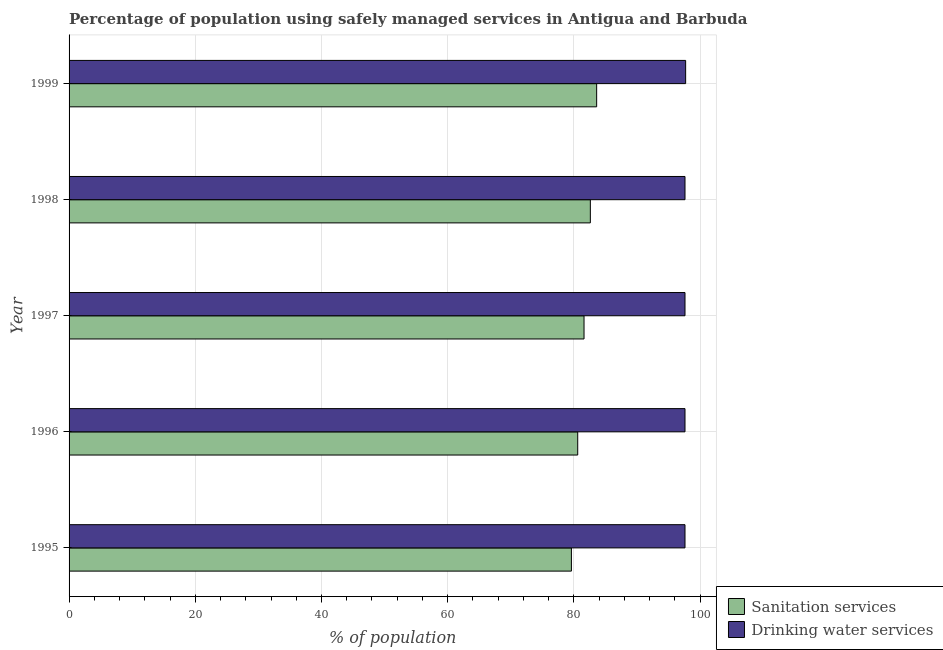In how many cases, is the number of bars for a given year not equal to the number of legend labels?
Your response must be concise. 0. What is the percentage of population who used sanitation services in 1998?
Ensure brevity in your answer.  82.6. Across all years, what is the maximum percentage of population who used drinking water services?
Ensure brevity in your answer.  97.7. Across all years, what is the minimum percentage of population who used sanitation services?
Your answer should be compact. 79.6. In which year was the percentage of population who used drinking water services minimum?
Your answer should be compact. 1995. What is the total percentage of population who used sanitation services in the graph?
Provide a succinct answer. 408. What is the difference between the percentage of population who used sanitation services in 1995 and that in 1998?
Provide a short and direct response. -3. What is the average percentage of population who used drinking water services per year?
Offer a terse response. 97.62. In the year 1995, what is the difference between the percentage of population who used sanitation services and percentage of population who used drinking water services?
Provide a succinct answer. -18. Is the percentage of population who used sanitation services in 1997 less than that in 1999?
Keep it short and to the point. Yes. Is the difference between the percentage of population who used sanitation services in 1995 and 1999 greater than the difference between the percentage of population who used drinking water services in 1995 and 1999?
Offer a very short reply. No. What is the difference between the highest and the second highest percentage of population who used drinking water services?
Keep it short and to the point. 0.1. What is the difference between the highest and the lowest percentage of population who used sanitation services?
Offer a terse response. 4. In how many years, is the percentage of population who used drinking water services greater than the average percentage of population who used drinking water services taken over all years?
Give a very brief answer. 1. What does the 2nd bar from the top in 1996 represents?
Provide a short and direct response. Sanitation services. What does the 1st bar from the bottom in 1999 represents?
Provide a short and direct response. Sanitation services. Does the graph contain any zero values?
Offer a very short reply. No. How are the legend labels stacked?
Your response must be concise. Vertical. What is the title of the graph?
Keep it short and to the point. Percentage of population using safely managed services in Antigua and Barbuda. Does "Number of arrivals" appear as one of the legend labels in the graph?
Offer a very short reply. No. What is the label or title of the X-axis?
Provide a short and direct response. % of population. What is the % of population of Sanitation services in 1995?
Your answer should be very brief. 79.6. What is the % of population of Drinking water services in 1995?
Make the answer very short. 97.6. What is the % of population of Sanitation services in 1996?
Your answer should be very brief. 80.6. What is the % of population in Drinking water services in 1996?
Give a very brief answer. 97.6. What is the % of population of Sanitation services in 1997?
Your response must be concise. 81.6. What is the % of population of Drinking water services in 1997?
Your answer should be very brief. 97.6. What is the % of population in Sanitation services in 1998?
Offer a very short reply. 82.6. What is the % of population of Drinking water services in 1998?
Offer a terse response. 97.6. What is the % of population of Sanitation services in 1999?
Provide a succinct answer. 83.6. What is the % of population in Drinking water services in 1999?
Keep it short and to the point. 97.7. Across all years, what is the maximum % of population of Sanitation services?
Ensure brevity in your answer.  83.6. Across all years, what is the maximum % of population of Drinking water services?
Keep it short and to the point. 97.7. Across all years, what is the minimum % of population in Sanitation services?
Your answer should be very brief. 79.6. Across all years, what is the minimum % of population of Drinking water services?
Provide a succinct answer. 97.6. What is the total % of population in Sanitation services in the graph?
Offer a terse response. 408. What is the total % of population in Drinking water services in the graph?
Your answer should be very brief. 488.1. What is the difference between the % of population of Sanitation services in 1995 and that in 1996?
Your answer should be compact. -1. What is the difference between the % of population in Drinking water services in 1995 and that in 1997?
Your answer should be very brief. 0. What is the difference between the % of population in Sanitation services in 1995 and that in 1998?
Offer a very short reply. -3. What is the difference between the % of population in Sanitation services in 1996 and that in 1997?
Keep it short and to the point. -1. What is the difference between the % of population of Drinking water services in 1996 and that in 1997?
Offer a terse response. 0. What is the difference between the % of population in Drinking water services in 1996 and that in 1998?
Make the answer very short. 0. What is the difference between the % of population of Sanitation services in 1996 and that in 1999?
Keep it short and to the point. -3. What is the difference between the % of population in Sanitation services in 1998 and that in 1999?
Your answer should be compact. -1. What is the difference between the % of population of Drinking water services in 1998 and that in 1999?
Keep it short and to the point. -0.1. What is the difference between the % of population of Sanitation services in 1995 and the % of population of Drinking water services in 1997?
Your answer should be compact. -18. What is the difference between the % of population of Sanitation services in 1995 and the % of population of Drinking water services in 1999?
Offer a terse response. -18.1. What is the difference between the % of population of Sanitation services in 1996 and the % of population of Drinking water services in 1997?
Provide a succinct answer. -17. What is the difference between the % of population of Sanitation services in 1996 and the % of population of Drinking water services in 1999?
Your answer should be very brief. -17.1. What is the difference between the % of population in Sanitation services in 1997 and the % of population in Drinking water services in 1998?
Your response must be concise. -16. What is the difference between the % of population of Sanitation services in 1997 and the % of population of Drinking water services in 1999?
Your response must be concise. -16.1. What is the difference between the % of population of Sanitation services in 1998 and the % of population of Drinking water services in 1999?
Ensure brevity in your answer.  -15.1. What is the average % of population in Sanitation services per year?
Your answer should be compact. 81.6. What is the average % of population in Drinking water services per year?
Give a very brief answer. 97.62. In the year 1995, what is the difference between the % of population of Sanitation services and % of population of Drinking water services?
Your response must be concise. -18. In the year 1998, what is the difference between the % of population of Sanitation services and % of population of Drinking water services?
Keep it short and to the point. -15. In the year 1999, what is the difference between the % of population of Sanitation services and % of population of Drinking water services?
Your answer should be very brief. -14.1. What is the ratio of the % of population of Sanitation services in 1995 to that in 1996?
Provide a succinct answer. 0.99. What is the ratio of the % of population in Drinking water services in 1995 to that in 1996?
Make the answer very short. 1. What is the ratio of the % of population of Sanitation services in 1995 to that in 1997?
Make the answer very short. 0.98. What is the ratio of the % of population in Sanitation services in 1995 to that in 1998?
Your response must be concise. 0.96. What is the ratio of the % of population in Drinking water services in 1995 to that in 1998?
Ensure brevity in your answer.  1. What is the ratio of the % of population in Sanitation services in 1995 to that in 1999?
Keep it short and to the point. 0.95. What is the ratio of the % of population in Drinking water services in 1995 to that in 1999?
Make the answer very short. 1. What is the ratio of the % of population of Sanitation services in 1996 to that in 1997?
Offer a terse response. 0.99. What is the ratio of the % of population of Sanitation services in 1996 to that in 1998?
Provide a succinct answer. 0.98. What is the ratio of the % of population in Drinking water services in 1996 to that in 1998?
Provide a short and direct response. 1. What is the ratio of the % of population of Sanitation services in 1996 to that in 1999?
Offer a very short reply. 0.96. What is the ratio of the % of population in Drinking water services in 1996 to that in 1999?
Your response must be concise. 1. What is the ratio of the % of population in Sanitation services in 1997 to that in 1998?
Your answer should be very brief. 0.99. What is the ratio of the % of population of Drinking water services in 1997 to that in 1998?
Give a very brief answer. 1. What is the ratio of the % of population in Sanitation services in 1997 to that in 1999?
Provide a short and direct response. 0.98. What is the difference between the highest and the second highest % of population in Sanitation services?
Your response must be concise. 1. What is the difference between the highest and the second highest % of population of Drinking water services?
Your answer should be very brief. 0.1. What is the difference between the highest and the lowest % of population of Sanitation services?
Offer a very short reply. 4. 